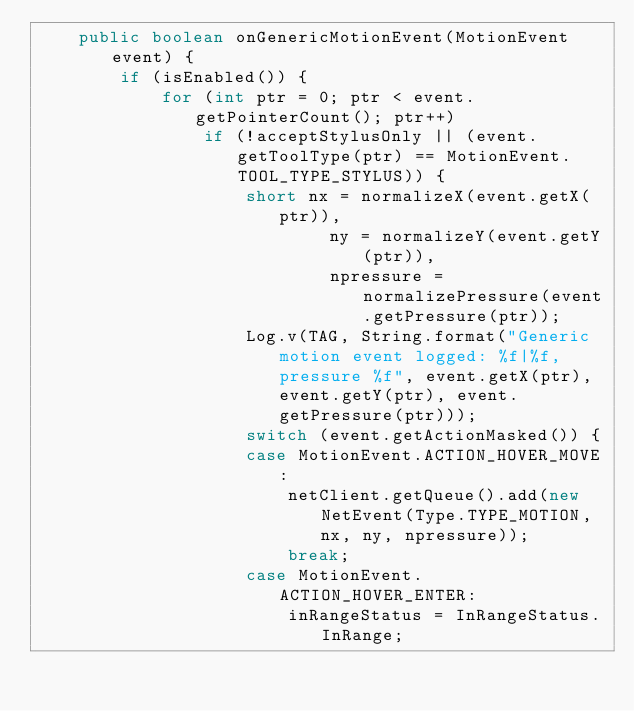Convert code to text. <code><loc_0><loc_0><loc_500><loc_500><_Java_>	public boolean onGenericMotionEvent(MotionEvent event) {
		if (isEnabled()) {
			for (int ptr = 0; ptr < event.getPointerCount(); ptr++)
				if (!acceptStylusOnly || (event.getToolType(ptr) == MotionEvent.TOOL_TYPE_STYLUS)) {
					short nx = normalizeX(event.getX(ptr)),
							ny = normalizeY(event.getY(ptr)),
							npressure = normalizePressure(event.getPressure(ptr));
					Log.v(TAG, String.format("Generic motion event logged: %f|%f, pressure %f", event.getX(ptr), event.getY(ptr), event.getPressure(ptr)));
					switch (event.getActionMasked()) {
					case MotionEvent.ACTION_HOVER_MOVE:
						netClient.getQueue().add(new NetEvent(Type.TYPE_MOTION, nx, ny, npressure));
						break;
					case MotionEvent.ACTION_HOVER_ENTER:
						inRangeStatus = InRangeStatus.InRange;</code> 